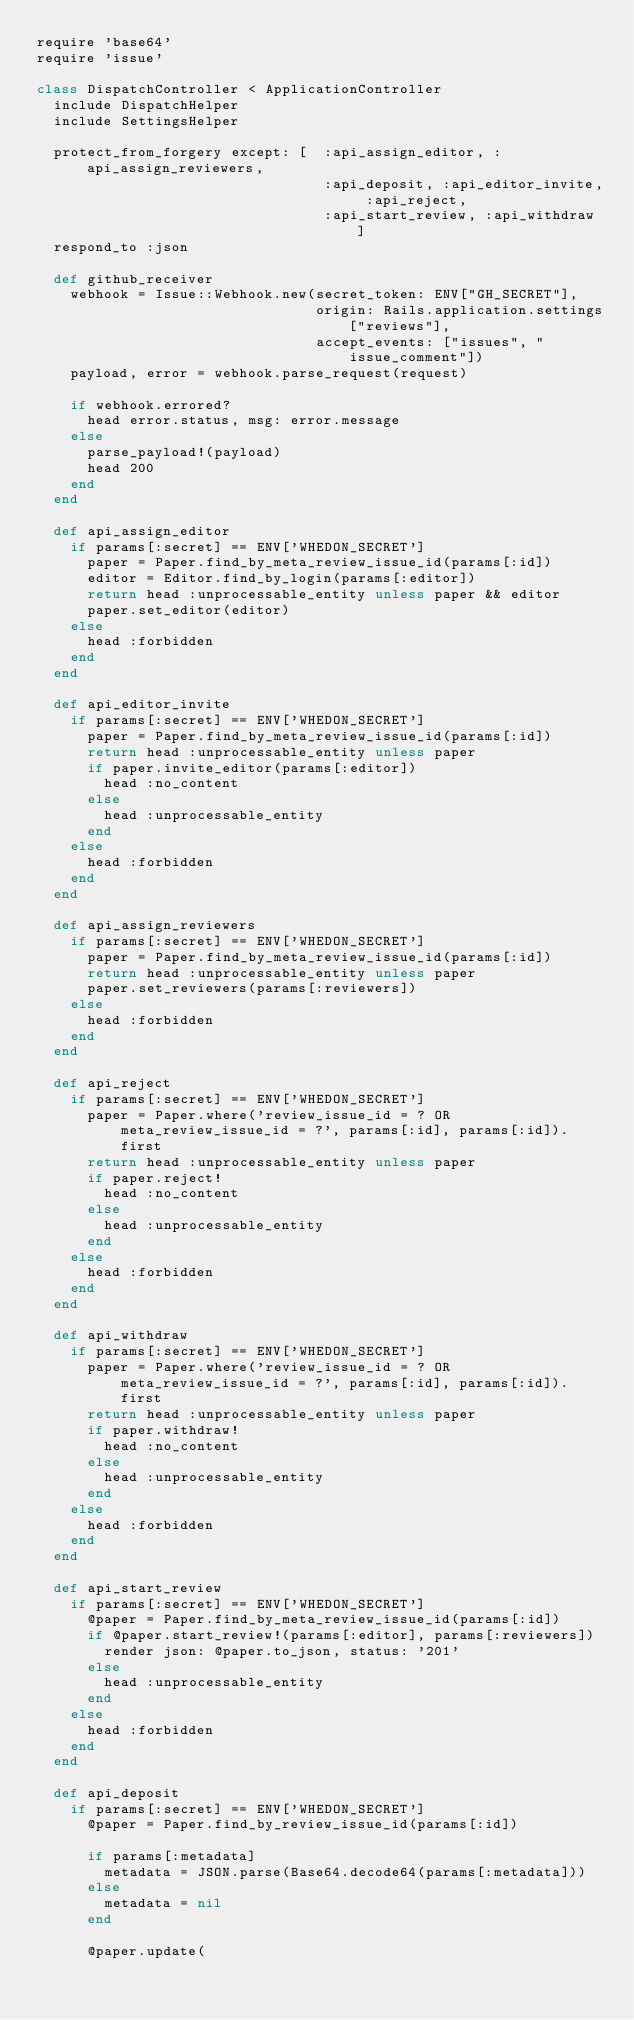<code> <loc_0><loc_0><loc_500><loc_500><_Ruby_>require 'base64'
require 'issue'

class DispatchController < ApplicationController
  include DispatchHelper
  include SettingsHelper

  protect_from_forgery except: [  :api_assign_editor, :api_assign_reviewers,
                                  :api_deposit, :api_editor_invite, :api_reject,
                                  :api_start_review, :api_withdraw ]
  respond_to :json

  def github_receiver
    webhook = Issue::Webhook.new(secret_token: ENV["GH_SECRET"],
                                 origin: Rails.application.settings["reviews"],
                                 accept_events: ["issues", "issue_comment"])
    payload, error = webhook.parse_request(request)

    if webhook.errored?
      head error.status, msg: error.message
    else
      parse_payload!(payload)
      head 200
    end
  end

  def api_assign_editor
    if params[:secret] == ENV['WHEDON_SECRET']
      paper = Paper.find_by_meta_review_issue_id(params[:id])
      editor = Editor.find_by_login(params[:editor])
      return head :unprocessable_entity unless paper && editor
      paper.set_editor(editor)
    else
      head :forbidden
    end
  end

  def api_editor_invite
    if params[:secret] == ENV['WHEDON_SECRET']
      paper = Paper.find_by_meta_review_issue_id(params[:id])
      return head :unprocessable_entity unless paper
      if paper.invite_editor(params[:editor])
        head :no_content
      else
        head :unprocessable_entity
      end
    else
      head :forbidden
    end
  end

  def api_assign_reviewers
    if params[:secret] == ENV['WHEDON_SECRET']
      paper = Paper.find_by_meta_review_issue_id(params[:id])
      return head :unprocessable_entity unless paper
      paper.set_reviewers(params[:reviewers])
    else
      head :forbidden
    end
  end

  def api_reject
    if params[:secret] == ENV['WHEDON_SECRET']
      paper = Paper.where('review_issue_id = ? OR meta_review_issue_id = ?', params[:id], params[:id]).first
      return head :unprocessable_entity unless paper
      if paper.reject!
        head :no_content
      else
        head :unprocessable_entity
      end
    else
      head :forbidden
    end
  end

  def api_withdraw
    if params[:secret] == ENV['WHEDON_SECRET']
      paper = Paper.where('review_issue_id = ? OR meta_review_issue_id = ?', params[:id], params[:id]).first
      return head :unprocessable_entity unless paper
      if paper.withdraw!
        head :no_content
      else
        head :unprocessable_entity
      end
    else
      head :forbidden
    end
  end

  def api_start_review
    if params[:secret] == ENV['WHEDON_SECRET']
      @paper = Paper.find_by_meta_review_issue_id(params[:id])
      if @paper.start_review!(params[:editor], params[:reviewers])
        render json: @paper.to_json, status: '201'
      else
        head :unprocessable_entity
      end
    else
      head :forbidden
    end
  end

  def api_deposit
    if params[:secret] == ENV['WHEDON_SECRET']
      @paper = Paper.find_by_review_issue_id(params[:id])

      if params[:metadata]
        metadata = JSON.parse(Base64.decode64(params[:metadata]))
      else
        metadata = nil
      end

      @paper.update(</code> 